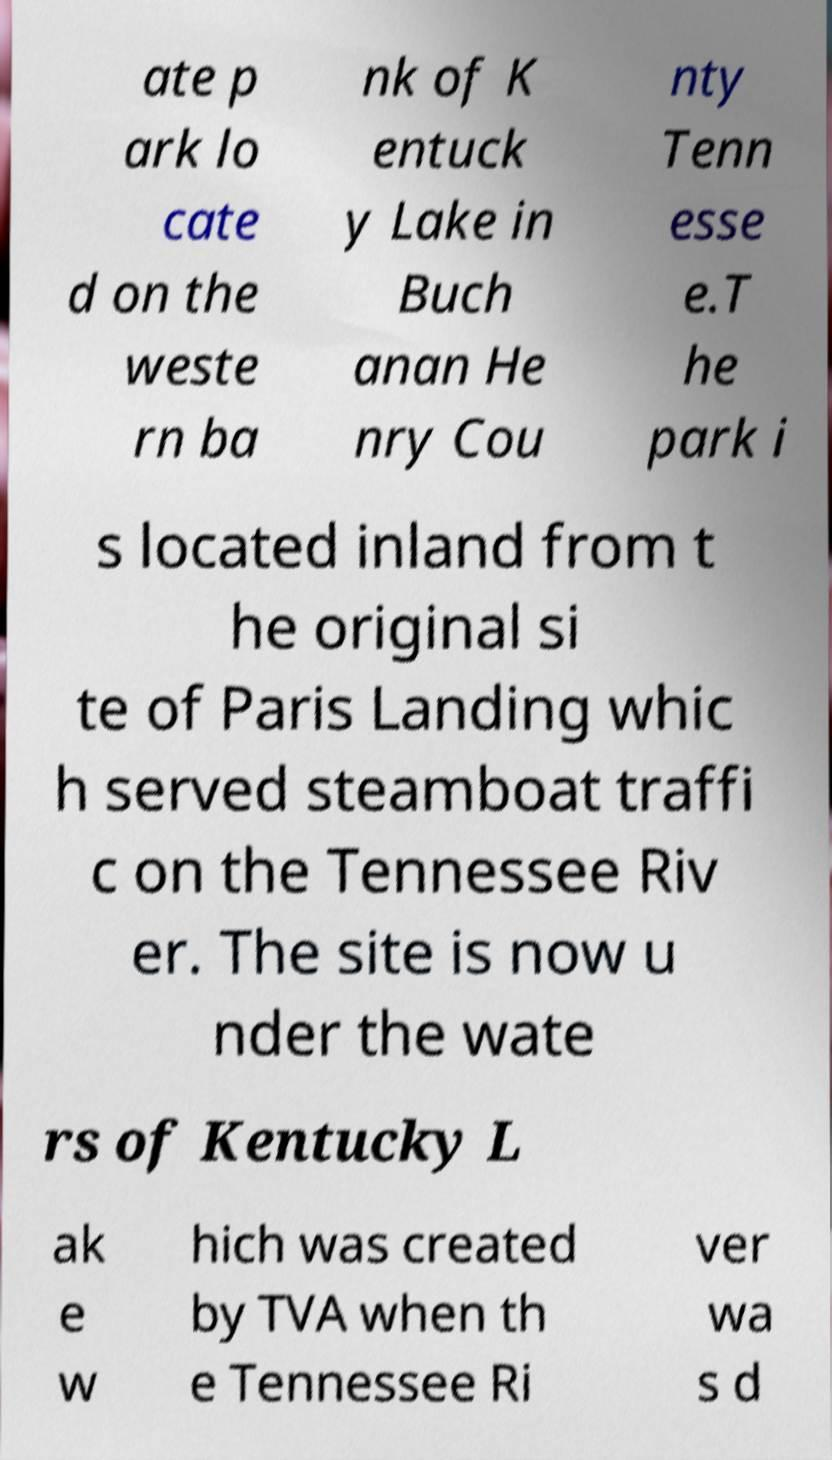I need the written content from this picture converted into text. Can you do that? ate p ark lo cate d on the weste rn ba nk of K entuck y Lake in Buch anan He nry Cou nty Tenn esse e.T he park i s located inland from t he original si te of Paris Landing whic h served steamboat traffi c on the Tennessee Riv er. The site is now u nder the wate rs of Kentucky L ak e w hich was created by TVA when th e Tennessee Ri ver wa s d 